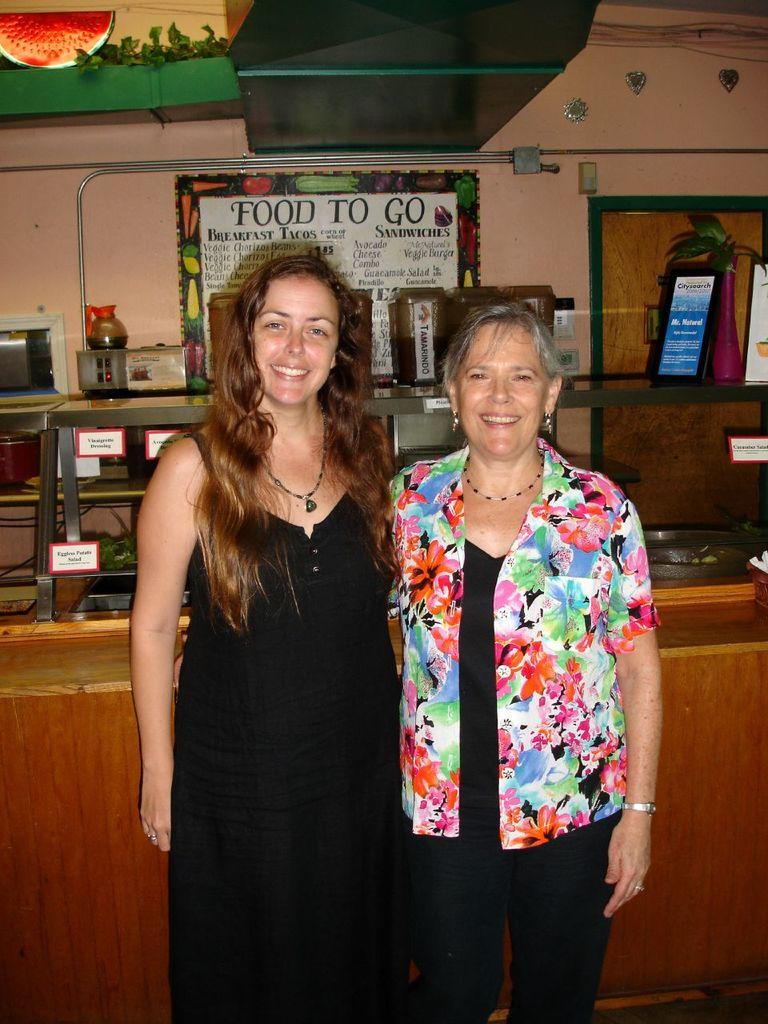How many people are present in the image? There are two people in the image. What are the people wearing? The people are wearing different color dresses. What can be seen in the background of the image? There are boards on a food stall and a wall in the background. What type of rose can be seen growing on the wall in the image? There is no rose present in the image; the background features boards on a wall, but no plants or flowers are visible. 